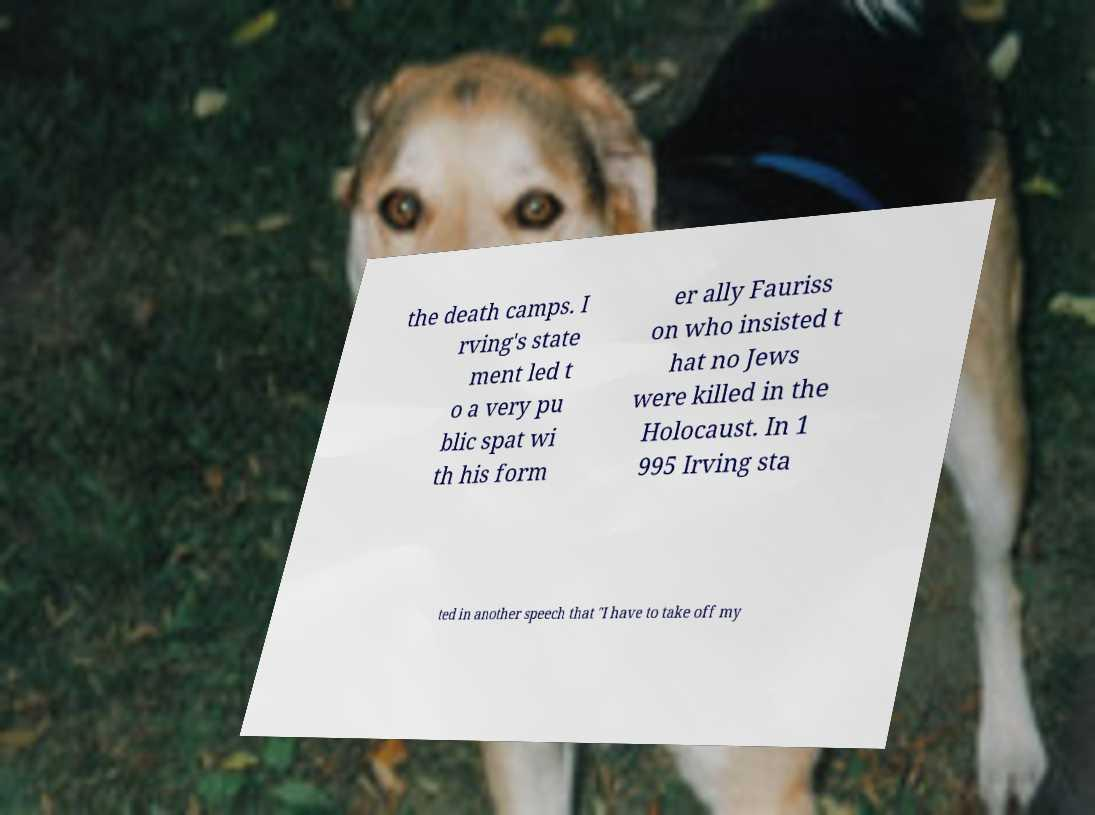Could you assist in decoding the text presented in this image and type it out clearly? the death camps. I rving's state ment led t o a very pu blic spat wi th his form er ally Fauriss on who insisted t hat no Jews were killed in the Holocaust. In 1 995 Irving sta ted in another speech that "I have to take off my 